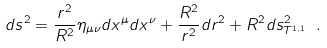Convert formula to latex. <formula><loc_0><loc_0><loc_500><loc_500>d s ^ { 2 } = \frac { r ^ { 2 } } { R ^ { 2 } } \eta _ { \mu \nu } d x ^ { \mu } d x ^ { \nu } + \frac { R ^ { 2 } } { r ^ { 2 } } d r ^ { 2 } + R ^ { 2 } d s ^ { 2 } _ { T ^ { 1 , 1 } } \ .</formula> 